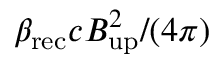Convert formula to latex. <formula><loc_0><loc_0><loc_500><loc_500>\beta _ { r e c } c B _ { u p } ^ { 2 } / ( 4 \pi )</formula> 